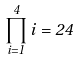Convert formula to latex. <formula><loc_0><loc_0><loc_500><loc_500>\prod _ { i = 1 } ^ { 4 } i = 2 4</formula> 